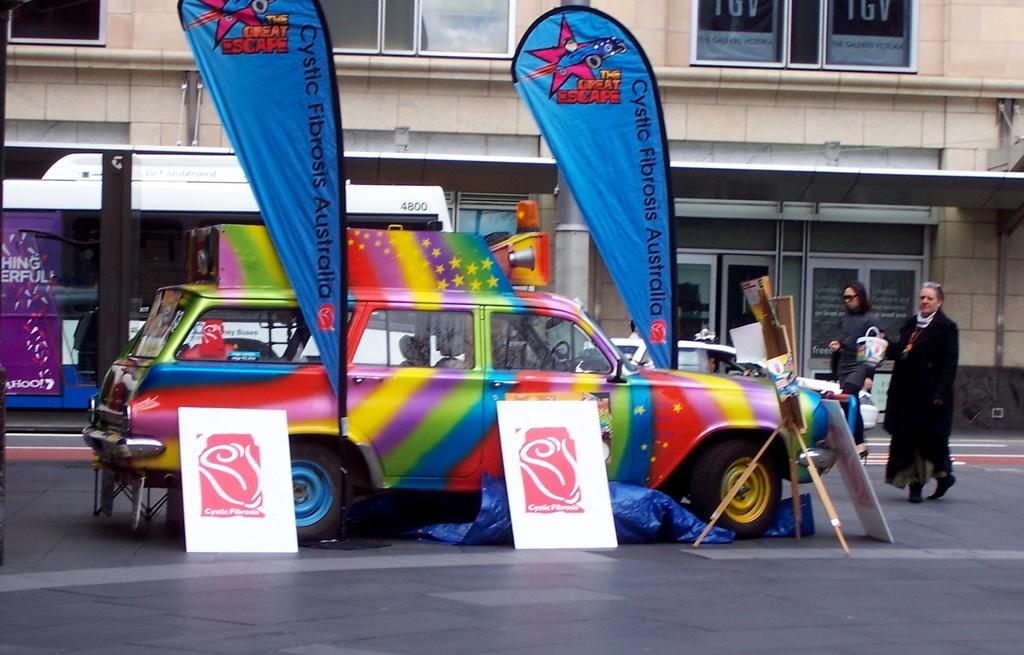What types of objects can be seen in the image? There are vehicles, banners, and boards in the image. What is on the floor in the image? There is a stand on the floor in the image. What are the people in the image doing? There are people walking in the image. What can be seen in the background of the image? There is a building and windows visible in the background of the image. What type of berry can be seen growing near the seashore in the image? There is no seashore or berry present in the image; it features vehicles, banners, boards, a stand, people walking, and a building in the background. What type of office furniture can be seen in the image? There is no office furniture present in the image. 